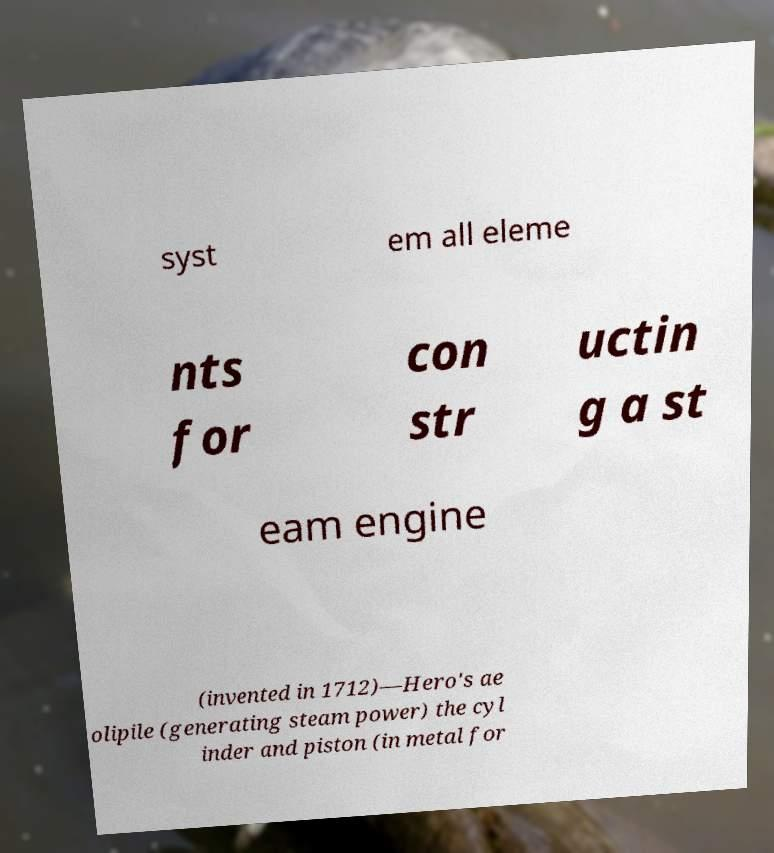Can you accurately transcribe the text from the provided image for me? syst em all eleme nts for con str uctin g a st eam engine (invented in 1712)—Hero's ae olipile (generating steam power) the cyl inder and piston (in metal for 